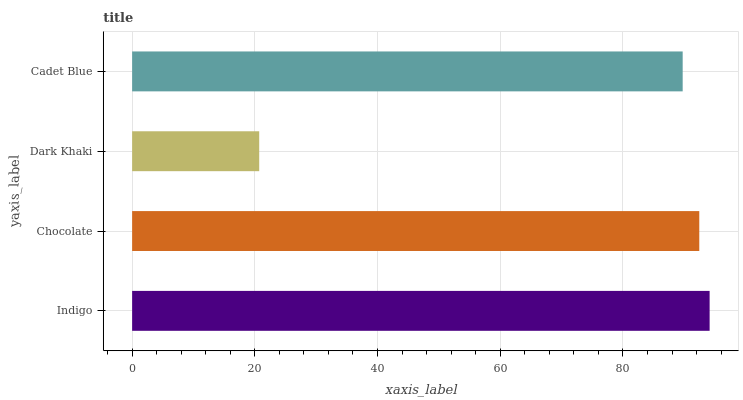Is Dark Khaki the minimum?
Answer yes or no. Yes. Is Indigo the maximum?
Answer yes or no. Yes. Is Chocolate the minimum?
Answer yes or no. No. Is Chocolate the maximum?
Answer yes or no. No. Is Indigo greater than Chocolate?
Answer yes or no. Yes. Is Chocolate less than Indigo?
Answer yes or no. Yes. Is Chocolate greater than Indigo?
Answer yes or no. No. Is Indigo less than Chocolate?
Answer yes or no. No. Is Chocolate the high median?
Answer yes or no. Yes. Is Cadet Blue the low median?
Answer yes or no. Yes. Is Dark Khaki the high median?
Answer yes or no. No. Is Chocolate the low median?
Answer yes or no. No. 